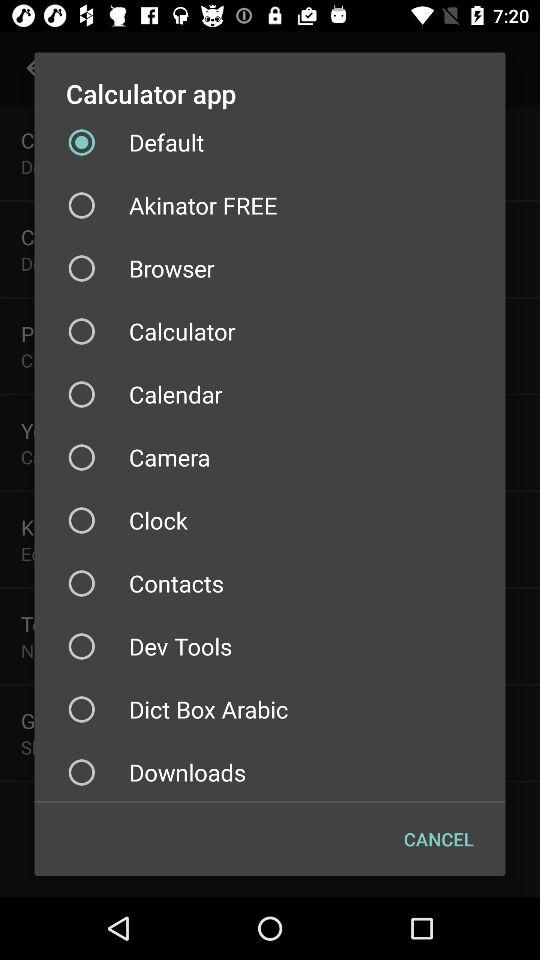What is the name of the application? The names of the applications are "Calculator", "Default", "Akinator FREE", "Browser", "Calendar", "Camera", "Clock", "Contacts", "Dev Tools" and "Dict Box Arabic". 